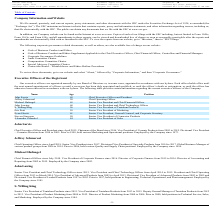According to Avx Corporation's financial document, Who is the Chief Executive Officer and President of the company? According to the financial document, John Sarvis. The relevant text states: "John Sarvis 69 Chief Executive Officer and President..." Also, Who is the Chief Operating Officer of the company? According to the financial document, Jeffrey Schmersal. The relevant text states: "Jeffrey Schmersal 50 Chief Operating Officer..." Also, Who is the Senior Vice President and Chief Financial of the company? According to the financial document, Michael Hufnagel. The relevant text states: "Michael Hufnagel 65 Senior Vice President and Chief Financial Officer..." Also, can you calculate: What is the average age of the company's Senior Vice Presidents? To answer this question, I need to perform calculations using the financial data. The calculation is: (65 + 68 + 56 + 59 + 61 + 50 + 44)/7 , which equals 57.57. This is based on the information: "S. Willing King 56 Senior Vice President of Tantalum Products Eric Pratt 59 Senior Vice President of Marketing Evan Slavitt 61 Senior Vice President, General Counsel, and Corporate Secretary John Lawi..." The key data points involved are: 44, 50, 56. Also, How many executive officers are there in the company?  Counting the relevant items in the document: John Sarvis ,  Jeffrey Schmersal ,  Michael Hufnagel ,  John Lawing ,  S. Willing King ,  Eric Pratt ,  Evan Slavitt ,  Steven Sturgeon ,  Alexander Schenkel, I find 9 instances. The key data points involved are: Alexander Schenkel, Eric Pratt, Evan Slavitt. Also, How many Senior Vice Presidents are there in the company? Counting the relevant items in the document: Michael Hufnagel ,  John Lawing ,  S. Willing King ,  Eric Pratt ,  Evan Slavitt ,  Steven Sturgeon ,  Alexander Schenkel, I find 7 instances. The key data points involved are: Alexander Schenkel, Eric Pratt, Evan Slavitt. 